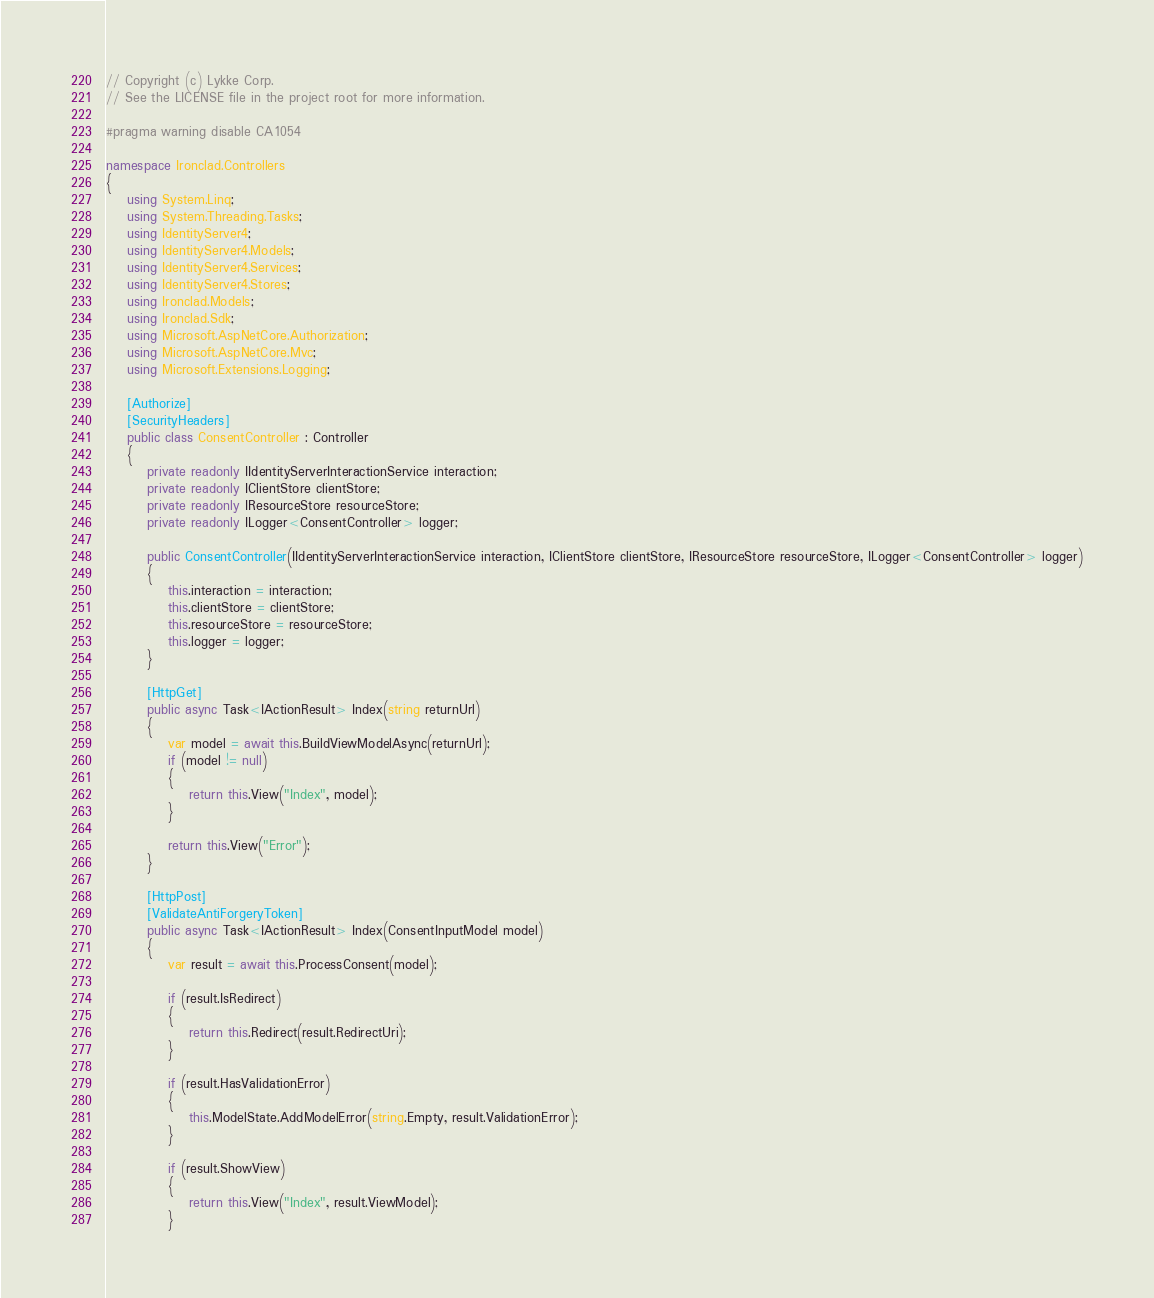<code> <loc_0><loc_0><loc_500><loc_500><_C#_>// Copyright (c) Lykke Corp.
// See the LICENSE file in the project root for more information.

#pragma warning disable CA1054

namespace Ironclad.Controllers
{
    using System.Linq;
    using System.Threading.Tasks;
    using IdentityServer4;
    using IdentityServer4.Models;
    using IdentityServer4.Services;
    using IdentityServer4.Stores;
    using Ironclad.Models;
    using Ironclad.Sdk;
    using Microsoft.AspNetCore.Authorization;
    using Microsoft.AspNetCore.Mvc;
    using Microsoft.Extensions.Logging;

    [Authorize]
    [SecurityHeaders]
    public class ConsentController : Controller
    {
        private readonly IIdentityServerInteractionService interaction;
        private readonly IClientStore clientStore;
        private readonly IResourceStore resourceStore;
        private readonly ILogger<ConsentController> logger;

        public ConsentController(IIdentityServerInteractionService interaction, IClientStore clientStore, IResourceStore resourceStore, ILogger<ConsentController> logger)
        {
            this.interaction = interaction;
            this.clientStore = clientStore;
            this.resourceStore = resourceStore;
            this.logger = logger;
        }

        [HttpGet]
        public async Task<IActionResult> Index(string returnUrl)
        {
            var model = await this.BuildViewModelAsync(returnUrl);
            if (model != null)
            {
                return this.View("Index", model);
            }

            return this.View("Error");
        }

        [HttpPost]
        [ValidateAntiForgeryToken]
        public async Task<IActionResult> Index(ConsentInputModel model)
        {
            var result = await this.ProcessConsent(model);

            if (result.IsRedirect)
            {
                return this.Redirect(result.RedirectUri);
            }

            if (result.HasValidationError)
            {
                this.ModelState.AddModelError(string.Empty, result.ValidationError);
            }

            if (result.ShowView)
            {
                return this.View("Index", result.ViewModel);
            }
</code> 